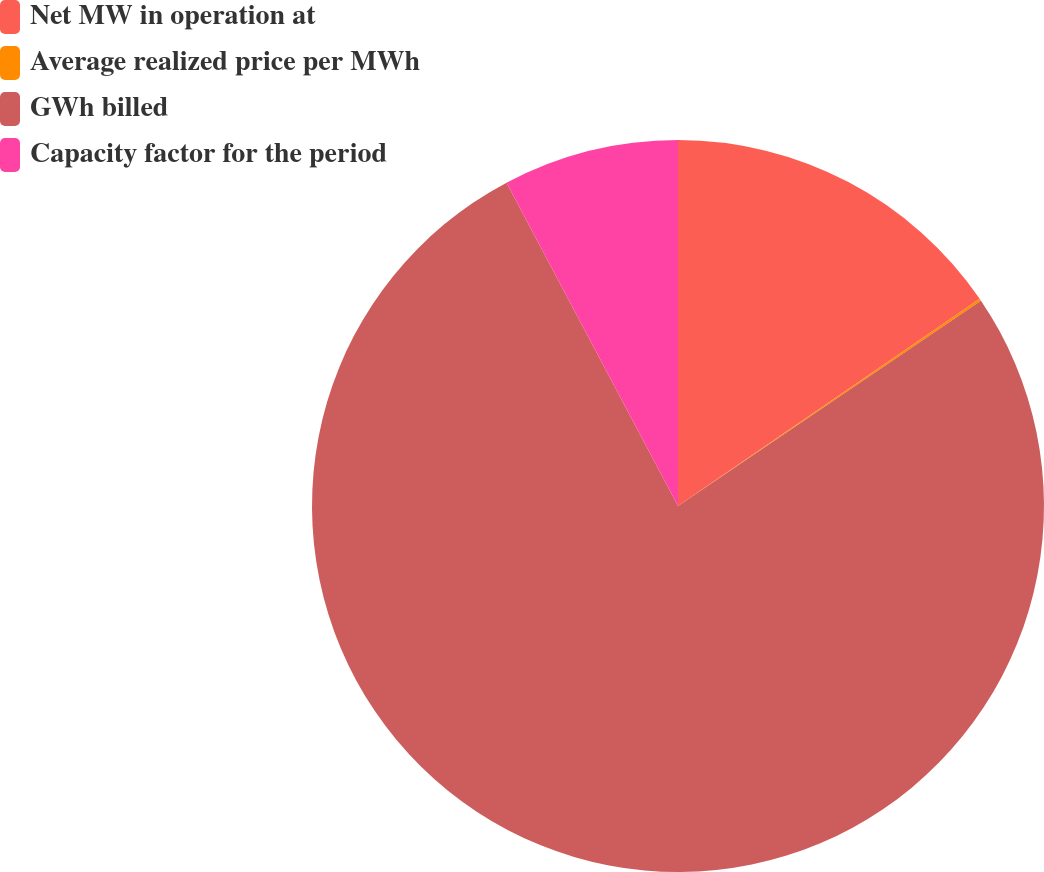<chart> <loc_0><loc_0><loc_500><loc_500><pie_chart><fcel>Net MW in operation at<fcel>Average realized price per MWh<fcel>GWh billed<fcel>Capacity factor for the period<nl><fcel>15.42%<fcel>0.1%<fcel>76.72%<fcel>7.76%<nl></chart> 